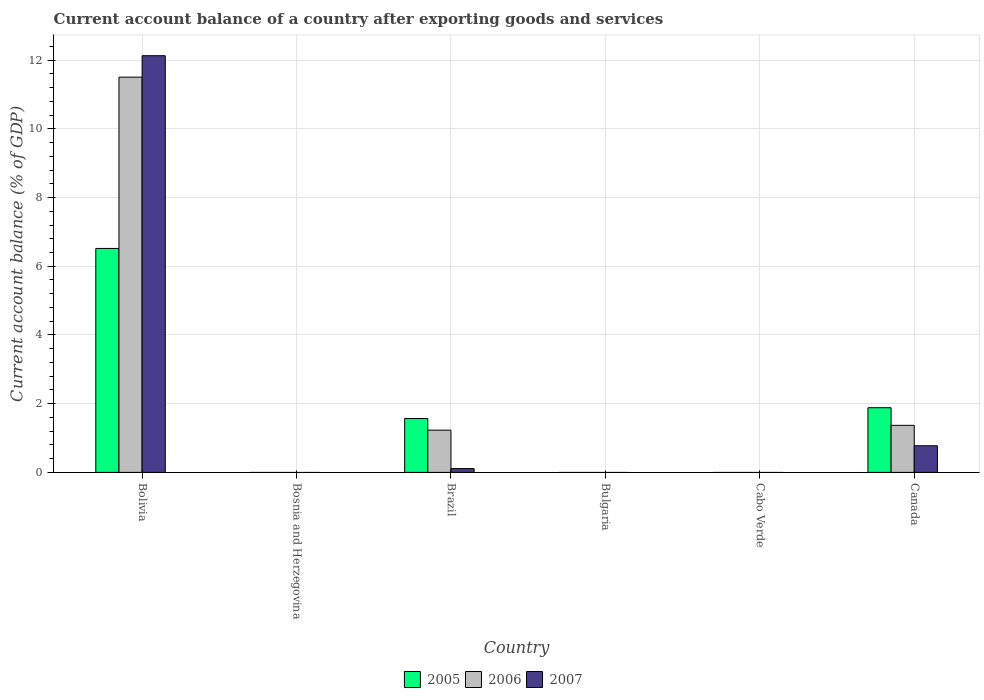How many different coloured bars are there?
Provide a short and direct response. 3. Are the number of bars per tick equal to the number of legend labels?
Offer a terse response. No. Are the number of bars on each tick of the X-axis equal?
Offer a terse response. No. What is the label of the 6th group of bars from the left?
Offer a terse response. Canada. In how many cases, is the number of bars for a given country not equal to the number of legend labels?
Make the answer very short. 3. What is the account balance in 2007 in Cabo Verde?
Give a very brief answer. 0. Across all countries, what is the maximum account balance in 2006?
Make the answer very short. 11.5. What is the total account balance in 2006 in the graph?
Provide a succinct answer. 14.1. What is the difference between the account balance in 2007 in Brazil and that in Canada?
Offer a terse response. -0.66. What is the difference between the account balance in 2007 in Bosnia and Herzegovina and the account balance in 2005 in Canada?
Offer a terse response. -1.88. What is the average account balance in 2005 per country?
Give a very brief answer. 1.66. What is the difference between the account balance of/in 2005 and account balance of/in 2006 in Canada?
Ensure brevity in your answer.  0.51. What is the ratio of the account balance in 2007 in Bolivia to that in Brazil?
Offer a very short reply. 109.17. What is the difference between the highest and the second highest account balance in 2007?
Give a very brief answer. -11.35. What is the difference between the highest and the lowest account balance in 2006?
Provide a succinct answer. 11.5. In how many countries, is the account balance in 2006 greater than the average account balance in 2006 taken over all countries?
Your response must be concise. 1. Is the sum of the account balance in 2006 in Bolivia and Brazil greater than the maximum account balance in 2007 across all countries?
Provide a short and direct response. Yes. How many countries are there in the graph?
Offer a very short reply. 6. Does the graph contain any zero values?
Your answer should be very brief. Yes. How are the legend labels stacked?
Give a very brief answer. Horizontal. What is the title of the graph?
Provide a succinct answer. Current account balance of a country after exporting goods and services. Does "1980" appear as one of the legend labels in the graph?
Make the answer very short. No. What is the label or title of the Y-axis?
Your answer should be very brief. Current account balance (% of GDP). What is the Current account balance (% of GDP) in 2005 in Bolivia?
Offer a very short reply. 6.52. What is the Current account balance (% of GDP) of 2006 in Bolivia?
Your answer should be very brief. 11.5. What is the Current account balance (% of GDP) in 2007 in Bolivia?
Provide a succinct answer. 12.13. What is the Current account balance (% of GDP) in 2005 in Bosnia and Herzegovina?
Give a very brief answer. 0. What is the Current account balance (% of GDP) in 2006 in Bosnia and Herzegovina?
Keep it short and to the point. 0. What is the Current account balance (% of GDP) in 2007 in Bosnia and Herzegovina?
Make the answer very short. 0. What is the Current account balance (% of GDP) in 2005 in Brazil?
Your answer should be compact. 1.57. What is the Current account balance (% of GDP) of 2006 in Brazil?
Offer a terse response. 1.23. What is the Current account balance (% of GDP) in 2007 in Brazil?
Make the answer very short. 0.11. What is the Current account balance (% of GDP) of 2005 in Canada?
Offer a very short reply. 1.88. What is the Current account balance (% of GDP) of 2006 in Canada?
Provide a succinct answer. 1.37. What is the Current account balance (% of GDP) of 2007 in Canada?
Provide a succinct answer. 0.78. Across all countries, what is the maximum Current account balance (% of GDP) in 2005?
Offer a very short reply. 6.52. Across all countries, what is the maximum Current account balance (% of GDP) of 2006?
Your answer should be very brief. 11.5. Across all countries, what is the maximum Current account balance (% of GDP) of 2007?
Your answer should be compact. 12.13. Across all countries, what is the minimum Current account balance (% of GDP) of 2005?
Provide a short and direct response. 0. What is the total Current account balance (% of GDP) of 2005 in the graph?
Make the answer very short. 9.97. What is the total Current account balance (% of GDP) of 2006 in the graph?
Your answer should be very brief. 14.1. What is the total Current account balance (% of GDP) of 2007 in the graph?
Provide a succinct answer. 13.01. What is the difference between the Current account balance (% of GDP) in 2005 in Bolivia and that in Brazil?
Provide a succinct answer. 4.95. What is the difference between the Current account balance (% of GDP) in 2006 in Bolivia and that in Brazil?
Provide a short and direct response. 10.27. What is the difference between the Current account balance (% of GDP) of 2007 in Bolivia and that in Brazil?
Your response must be concise. 12.02. What is the difference between the Current account balance (% of GDP) of 2005 in Bolivia and that in Canada?
Your answer should be compact. 4.64. What is the difference between the Current account balance (% of GDP) in 2006 in Bolivia and that in Canada?
Keep it short and to the point. 10.13. What is the difference between the Current account balance (% of GDP) in 2007 in Bolivia and that in Canada?
Your answer should be very brief. 11.35. What is the difference between the Current account balance (% of GDP) of 2005 in Brazil and that in Canada?
Make the answer very short. -0.31. What is the difference between the Current account balance (% of GDP) of 2006 in Brazil and that in Canada?
Provide a succinct answer. -0.14. What is the difference between the Current account balance (% of GDP) of 2007 in Brazil and that in Canada?
Ensure brevity in your answer.  -0.66. What is the difference between the Current account balance (% of GDP) of 2005 in Bolivia and the Current account balance (% of GDP) of 2006 in Brazil?
Keep it short and to the point. 5.29. What is the difference between the Current account balance (% of GDP) in 2005 in Bolivia and the Current account balance (% of GDP) in 2007 in Brazil?
Give a very brief answer. 6.41. What is the difference between the Current account balance (% of GDP) of 2006 in Bolivia and the Current account balance (% of GDP) of 2007 in Brazil?
Your answer should be very brief. 11.39. What is the difference between the Current account balance (% of GDP) of 2005 in Bolivia and the Current account balance (% of GDP) of 2006 in Canada?
Give a very brief answer. 5.15. What is the difference between the Current account balance (% of GDP) of 2005 in Bolivia and the Current account balance (% of GDP) of 2007 in Canada?
Make the answer very short. 5.74. What is the difference between the Current account balance (% of GDP) of 2006 in Bolivia and the Current account balance (% of GDP) of 2007 in Canada?
Give a very brief answer. 10.73. What is the difference between the Current account balance (% of GDP) in 2005 in Brazil and the Current account balance (% of GDP) in 2006 in Canada?
Provide a succinct answer. 0.2. What is the difference between the Current account balance (% of GDP) of 2005 in Brazil and the Current account balance (% of GDP) of 2007 in Canada?
Your answer should be compact. 0.79. What is the difference between the Current account balance (% of GDP) in 2006 in Brazil and the Current account balance (% of GDP) in 2007 in Canada?
Ensure brevity in your answer.  0.45. What is the average Current account balance (% of GDP) of 2005 per country?
Make the answer very short. 1.66. What is the average Current account balance (% of GDP) of 2006 per country?
Keep it short and to the point. 2.35. What is the average Current account balance (% of GDP) in 2007 per country?
Your answer should be very brief. 2.17. What is the difference between the Current account balance (% of GDP) of 2005 and Current account balance (% of GDP) of 2006 in Bolivia?
Your response must be concise. -4.99. What is the difference between the Current account balance (% of GDP) in 2005 and Current account balance (% of GDP) in 2007 in Bolivia?
Your response must be concise. -5.61. What is the difference between the Current account balance (% of GDP) of 2006 and Current account balance (% of GDP) of 2007 in Bolivia?
Keep it short and to the point. -0.62. What is the difference between the Current account balance (% of GDP) of 2005 and Current account balance (% of GDP) of 2006 in Brazil?
Offer a terse response. 0.34. What is the difference between the Current account balance (% of GDP) of 2005 and Current account balance (% of GDP) of 2007 in Brazil?
Offer a very short reply. 1.46. What is the difference between the Current account balance (% of GDP) of 2006 and Current account balance (% of GDP) of 2007 in Brazil?
Your answer should be very brief. 1.12. What is the difference between the Current account balance (% of GDP) of 2005 and Current account balance (% of GDP) of 2006 in Canada?
Offer a terse response. 0.51. What is the difference between the Current account balance (% of GDP) of 2005 and Current account balance (% of GDP) of 2007 in Canada?
Make the answer very short. 1.11. What is the difference between the Current account balance (% of GDP) of 2006 and Current account balance (% of GDP) of 2007 in Canada?
Ensure brevity in your answer.  0.59. What is the ratio of the Current account balance (% of GDP) in 2005 in Bolivia to that in Brazil?
Ensure brevity in your answer.  4.16. What is the ratio of the Current account balance (% of GDP) in 2006 in Bolivia to that in Brazil?
Offer a very short reply. 9.36. What is the ratio of the Current account balance (% of GDP) of 2007 in Bolivia to that in Brazil?
Ensure brevity in your answer.  109.17. What is the ratio of the Current account balance (% of GDP) in 2005 in Bolivia to that in Canada?
Provide a succinct answer. 3.46. What is the ratio of the Current account balance (% of GDP) of 2006 in Bolivia to that in Canada?
Provide a short and direct response. 8.4. What is the ratio of the Current account balance (% of GDP) of 2007 in Bolivia to that in Canada?
Offer a terse response. 15.64. What is the ratio of the Current account balance (% of GDP) in 2005 in Brazil to that in Canada?
Make the answer very short. 0.83. What is the ratio of the Current account balance (% of GDP) of 2006 in Brazil to that in Canada?
Your answer should be very brief. 0.9. What is the ratio of the Current account balance (% of GDP) in 2007 in Brazil to that in Canada?
Give a very brief answer. 0.14. What is the difference between the highest and the second highest Current account balance (% of GDP) in 2005?
Keep it short and to the point. 4.64. What is the difference between the highest and the second highest Current account balance (% of GDP) of 2006?
Make the answer very short. 10.13. What is the difference between the highest and the second highest Current account balance (% of GDP) in 2007?
Your response must be concise. 11.35. What is the difference between the highest and the lowest Current account balance (% of GDP) of 2005?
Ensure brevity in your answer.  6.52. What is the difference between the highest and the lowest Current account balance (% of GDP) of 2006?
Make the answer very short. 11.5. What is the difference between the highest and the lowest Current account balance (% of GDP) in 2007?
Provide a succinct answer. 12.13. 